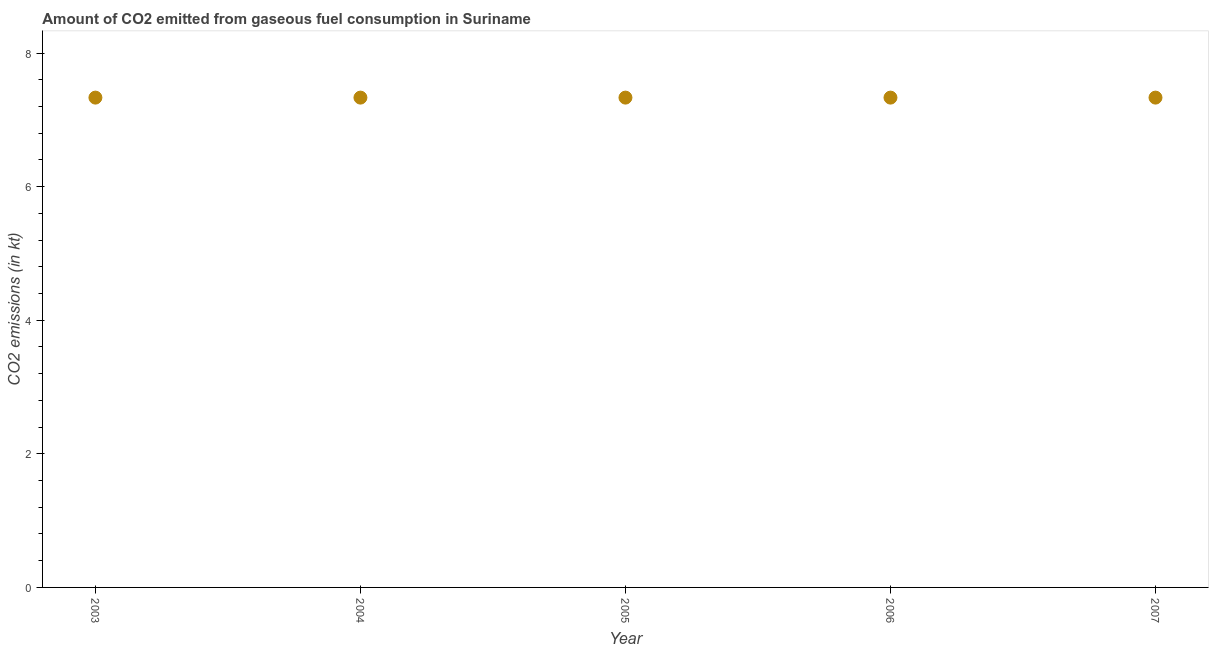What is the co2 emissions from gaseous fuel consumption in 2007?
Make the answer very short. 7.33. Across all years, what is the maximum co2 emissions from gaseous fuel consumption?
Keep it short and to the point. 7.33. Across all years, what is the minimum co2 emissions from gaseous fuel consumption?
Your answer should be very brief. 7.33. In which year was the co2 emissions from gaseous fuel consumption minimum?
Ensure brevity in your answer.  2003. What is the sum of the co2 emissions from gaseous fuel consumption?
Make the answer very short. 36.67. What is the difference between the co2 emissions from gaseous fuel consumption in 2005 and 2006?
Ensure brevity in your answer.  0. What is the average co2 emissions from gaseous fuel consumption per year?
Keep it short and to the point. 7.33. What is the median co2 emissions from gaseous fuel consumption?
Your answer should be very brief. 7.33. Do a majority of the years between 2005 and 2007 (inclusive) have co2 emissions from gaseous fuel consumption greater than 1.6 kt?
Your response must be concise. Yes. Is the co2 emissions from gaseous fuel consumption in 2004 less than that in 2006?
Keep it short and to the point. No. Is the difference between the co2 emissions from gaseous fuel consumption in 2003 and 2005 greater than the difference between any two years?
Your response must be concise. Yes. Is the sum of the co2 emissions from gaseous fuel consumption in 2005 and 2006 greater than the maximum co2 emissions from gaseous fuel consumption across all years?
Keep it short and to the point. Yes. What is the difference between the highest and the lowest co2 emissions from gaseous fuel consumption?
Offer a terse response. 0. Does the co2 emissions from gaseous fuel consumption monotonically increase over the years?
Provide a succinct answer. No. How many dotlines are there?
Keep it short and to the point. 1. How many years are there in the graph?
Ensure brevity in your answer.  5. What is the difference between two consecutive major ticks on the Y-axis?
Your answer should be very brief. 2. Does the graph contain grids?
Make the answer very short. No. What is the title of the graph?
Offer a very short reply. Amount of CO2 emitted from gaseous fuel consumption in Suriname. What is the label or title of the Y-axis?
Offer a terse response. CO2 emissions (in kt). What is the CO2 emissions (in kt) in 2003?
Make the answer very short. 7.33. What is the CO2 emissions (in kt) in 2004?
Your answer should be very brief. 7.33. What is the CO2 emissions (in kt) in 2005?
Provide a short and direct response. 7.33. What is the CO2 emissions (in kt) in 2006?
Your answer should be compact. 7.33. What is the CO2 emissions (in kt) in 2007?
Keep it short and to the point. 7.33. What is the difference between the CO2 emissions (in kt) in 2003 and 2005?
Your response must be concise. 0. What is the difference between the CO2 emissions (in kt) in 2003 and 2007?
Offer a terse response. 0. What is the difference between the CO2 emissions (in kt) in 2004 and 2005?
Your answer should be compact. 0. What is the difference between the CO2 emissions (in kt) in 2004 and 2006?
Keep it short and to the point. 0. What is the difference between the CO2 emissions (in kt) in 2004 and 2007?
Ensure brevity in your answer.  0. What is the difference between the CO2 emissions (in kt) in 2005 and 2006?
Offer a terse response. 0. What is the difference between the CO2 emissions (in kt) in 2006 and 2007?
Provide a short and direct response. 0. What is the ratio of the CO2 emissions (in kt) in 2003 to that in 2004?
Keep it short and to the point. 1. What is the ratio of the CO2 emissions (in kt) in 2003 to that in 2005?
Your response must be concise. 1. What is the ratio of the CO2 emissions (in kt) in 2004 to that in 2006?
Your answer should be compact. 1. What is the ratio of the CO2 emissions (in kt) in 2005 to that in 2006?
Ensure brevity in your answer.  1. What is the ratio of the CO2 emissions (in kt) in 2006 to that in 2007?
Your answer should be compact. 1. 